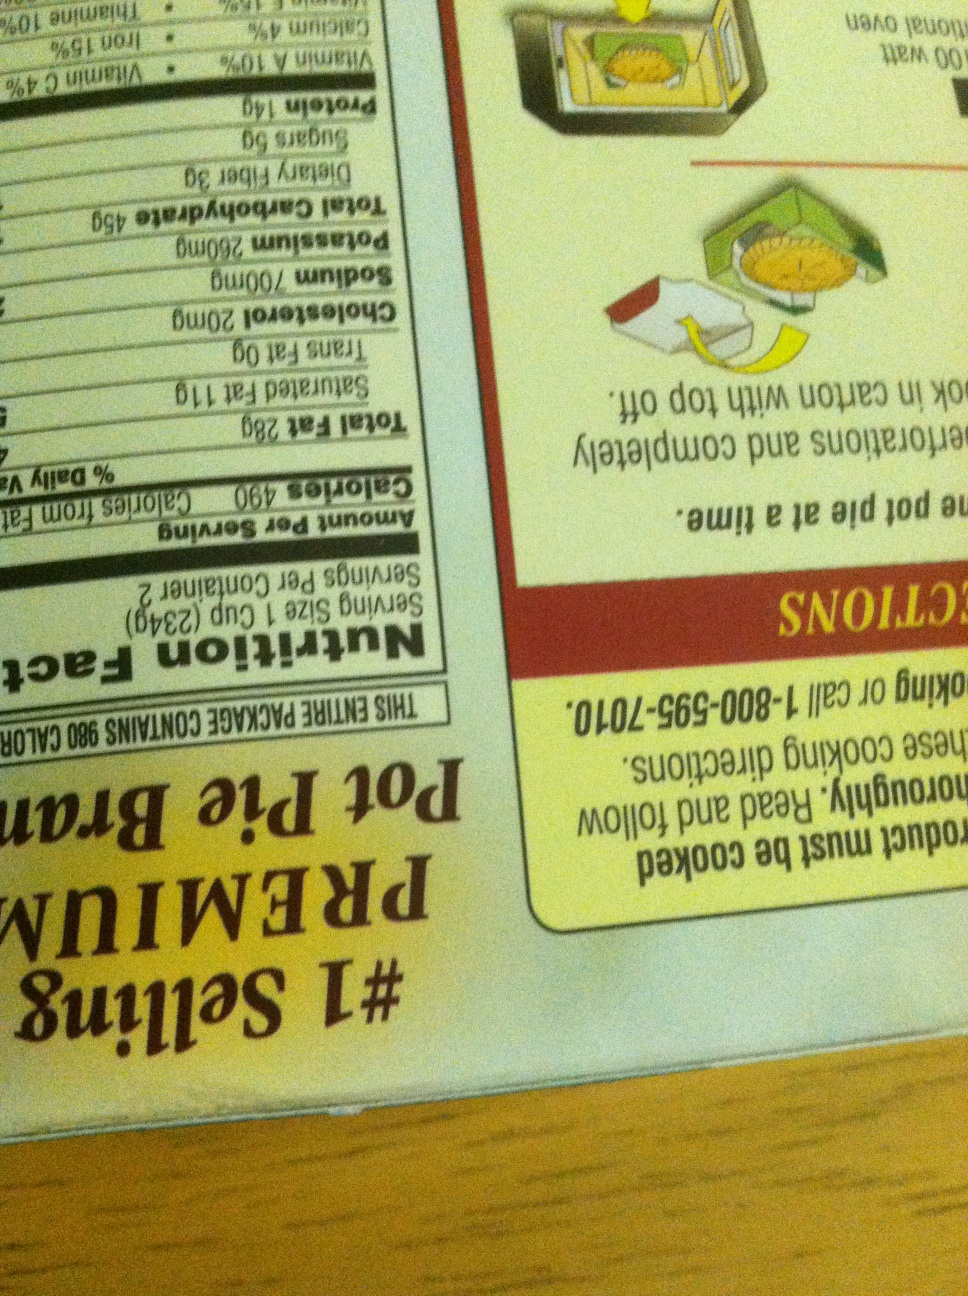Can you provide a detailed description of the cooking instructions for this pot pie? Certainly! Here are the detailed cooking instructions for the pot pie:
1. Preheat your oven to 375°F (190°C).
2. Remove the pot pie from its outer carton, but keep it in its paper tray.
3. Place the pot pie on a baking sheet to catch any potential spills.
4. Cook for approximately 60 to 65 minutes or until the crust is golden brown and the filling is bubbling.
5. If using a microwave oven, the cooking time varies and it's recommended to follow the specific microwave instructions provided on the package.
6. After cooking, carefully remove the pot pie from the oven and let it sit for 5 minutes before serving to allow the filling to set and cool slightly.
Enjoy your delicious meal! Can you create a short backstory for the pot pie brand? Sure! This pot pie brand started in a small family kitchen where recipes were passed down through generations. Each pot pie is crafted with love and care, using the finest ingredients to ensure a homemade taste in every bite. Today, the brand continues to uphold its tradition of quality, bringing comfort and joy to households all over the country. If this pot pie could speak, what story would it tell? Once upon a time, in a cozy little kitchen, a humble pot pie dreamed of bringing warmth and satisfaction to dinner tables everywhere. Made with tender chunks of chicken, hearty vegetables, and a rich, savory gravy, it worked its way up from local farmers' markets to supermarket shelves. It would tell stories of festive family dinners, comforting meals on cold winter nights, and the joy of sharing a delicious, wholesome meal with loved ones. Each flaky bite would be a testament to its journey from a simple, lovingly crafted recipe to a beloved staple in homes across the nation. 